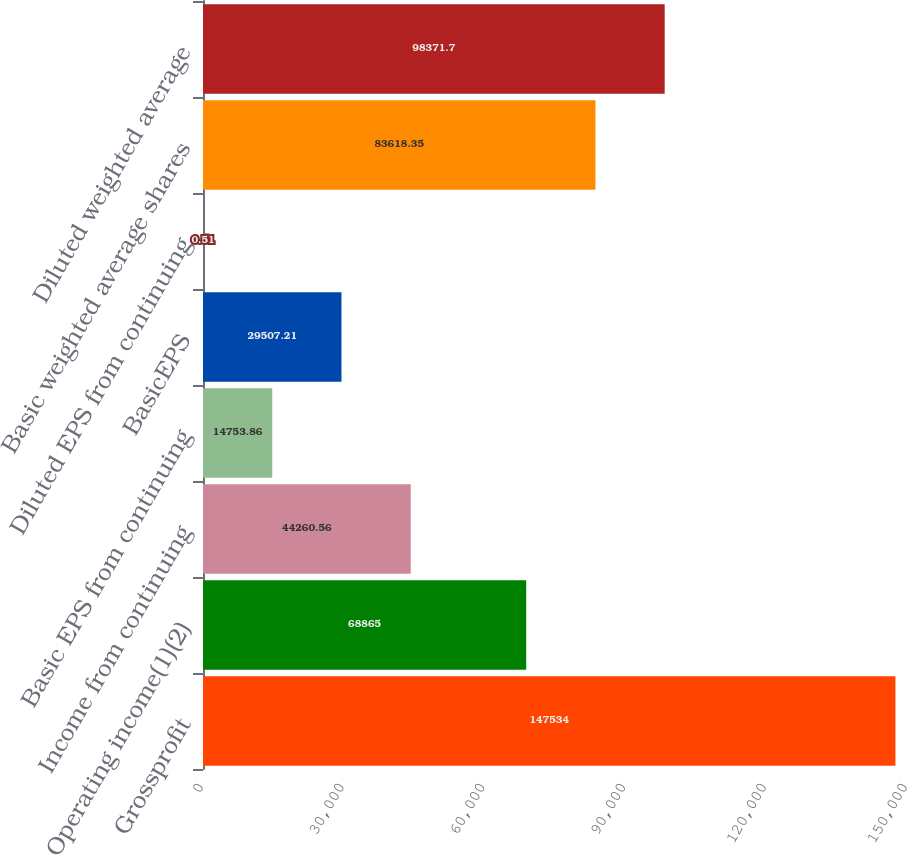Convert chart. <chart><loc_0><loc_0><loc_500><loc_500><bar_chart><fcel>Grossprofit<fcel>Operating income(1)(2)<fcel>Income from continuing<fcel>Basic EPS from continuing<fcel>BasicEPS<fcel>Diluted EPS from continuing<fcel>Basic weighted average shares<fcel>Diluted weighted average<nl><fcel>147534<fcel>68865<fcel>44260.6<fcel>14753.9<fcel>29507.2<fcel>0.51<fcel>83618.4<fcel>98371.7<nl></chart> 